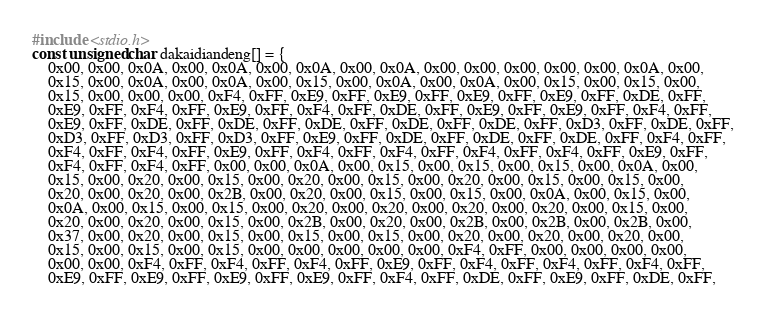Convert code to text. <code><loc_0><loc_0><loc_500><loc_500><_C_>#include <stdio.h>
const unsigned char dakaidiandeng[] = {
    0x00, 0x00, 0x0A, 0x00, 0x0A, 0x00, 0x0A, 0x00, 0x0A, 0x00, 0x00, 0x00, 0x00, 0x00, 0x0A, 0x00, 
    0x15, 0x00, 0x0A, 0x00, 0x0A, 0x00, 0x15, 0x00, 0x0A, 0x00, 0x0A, 0x00, 0x15, 0x00, 0x15, 0x00, 
    0x15, 0x00, 0x00, 0x00, 0xF4, 0xFF, 0xE9, 0xFF, 0xE9, 0xFF, 0xE9, 0xFF, 0xE9, 0xFF, 0xDE, 0xFF, 
    0xE9, 0xFF, 0xF4, 0xFF, 0xE9, 0xFF, 0xF4, 0xFF, 0xDE, 0xFF, 0xE9, 0xFF, 0xE9, 0xFF, 0xF4, 0xFF, 
    0xE9, 0xFF, 0xDE, 0xFF, 0xDE, 0xFF, 0xDE, 0xFF, 0xDE, 0xFF, 0xDE, 0xFF, 0xD3, 0xFF, 0xDE, 0xFF, 
    0xD3, 0xFF, 0xD3, 0xFF, 0xD3, 0xFF, 0xE9, 0xFF, 0xDE, 0xFF, 0xDE, 0xFF, 0xDE, 0xFF, 0xF4, 0xFF, 
    0xF4, 0xFF, 0xF4, 0xFF, 0xE9, 0xFF, 0xF4, 0xFF, 0xF4, 0xFF, 0xF4, 0xFF, 0xF4, 0xFF, 0xE9, 0xFF, 
    0xF4, 0xFF, 0xF4, 0xFF, 0x00, 0x00, 0x0A, 0x00, 0x15, 0x00, 0x15, 0x00, 0x15, 0x00, 0x0A, 0x00, 
    0x15, 0x00, 0x20, 0x00, 0x15, 0x00, 0x20, 0x00, 0x15, 0x00, 0x20, 0x00, 0x15, 0x00, 0x15, 0x00, 
    0x20, 0x00, 0x20, 0x00, 0x2B, 0x00, 0x20, 0x00, 0x15, 0x00, 0x15, 0x00, 0x0A, 0x00, 0x15, 0x00, 
    0x0A, 0x00, 0x15, 0x00, 0x15, 0x00, 0x20, 0x00, 0x20, 0x00, 0x20, 0x00, 0x20, 0x00, 0x15, 0x00, 
    0x20, 0x00, 0x20, 0x00, 0x15, 0x00, 0x2B, 0x00, 0x20, 0x00, 0x2B, 0x00, 0x2B, 0x00, 0x2B, 0x00, 
    0x37, 0x00, 0x20, 0x00, 0x15, 0x00, 0x15, 0x00, 0x15, 0x00, 0x20, 0x00, 0x20, 0x00, 0x20, 0x00, 
    0x15, 0x00, 0x15, 0x00, 0x15, 0x00, 0x00, 0x00, 0x00, 0x00, 0xF4, 0xFF, 0x00, 0x00, 0x00, 0x00, 
    0x00, 0x00, 0xF4, 0xFF, 0xF4, 0xFF, 0xF4, 0xFF, 0xE9, 0xFF, 0xF4, 0xFF, 0xF4, 0xFF, 0xF4, 0xFF, 
    0xE9, 0xFF, 0xE9, 0xFF, 0xE9, 0xFF, 0xE9, 0xFF, 0xF4, 0xFF, 0xDE, 0xFF, 0xE9, 0xFF, 0xDE, 0xFF, </code> 